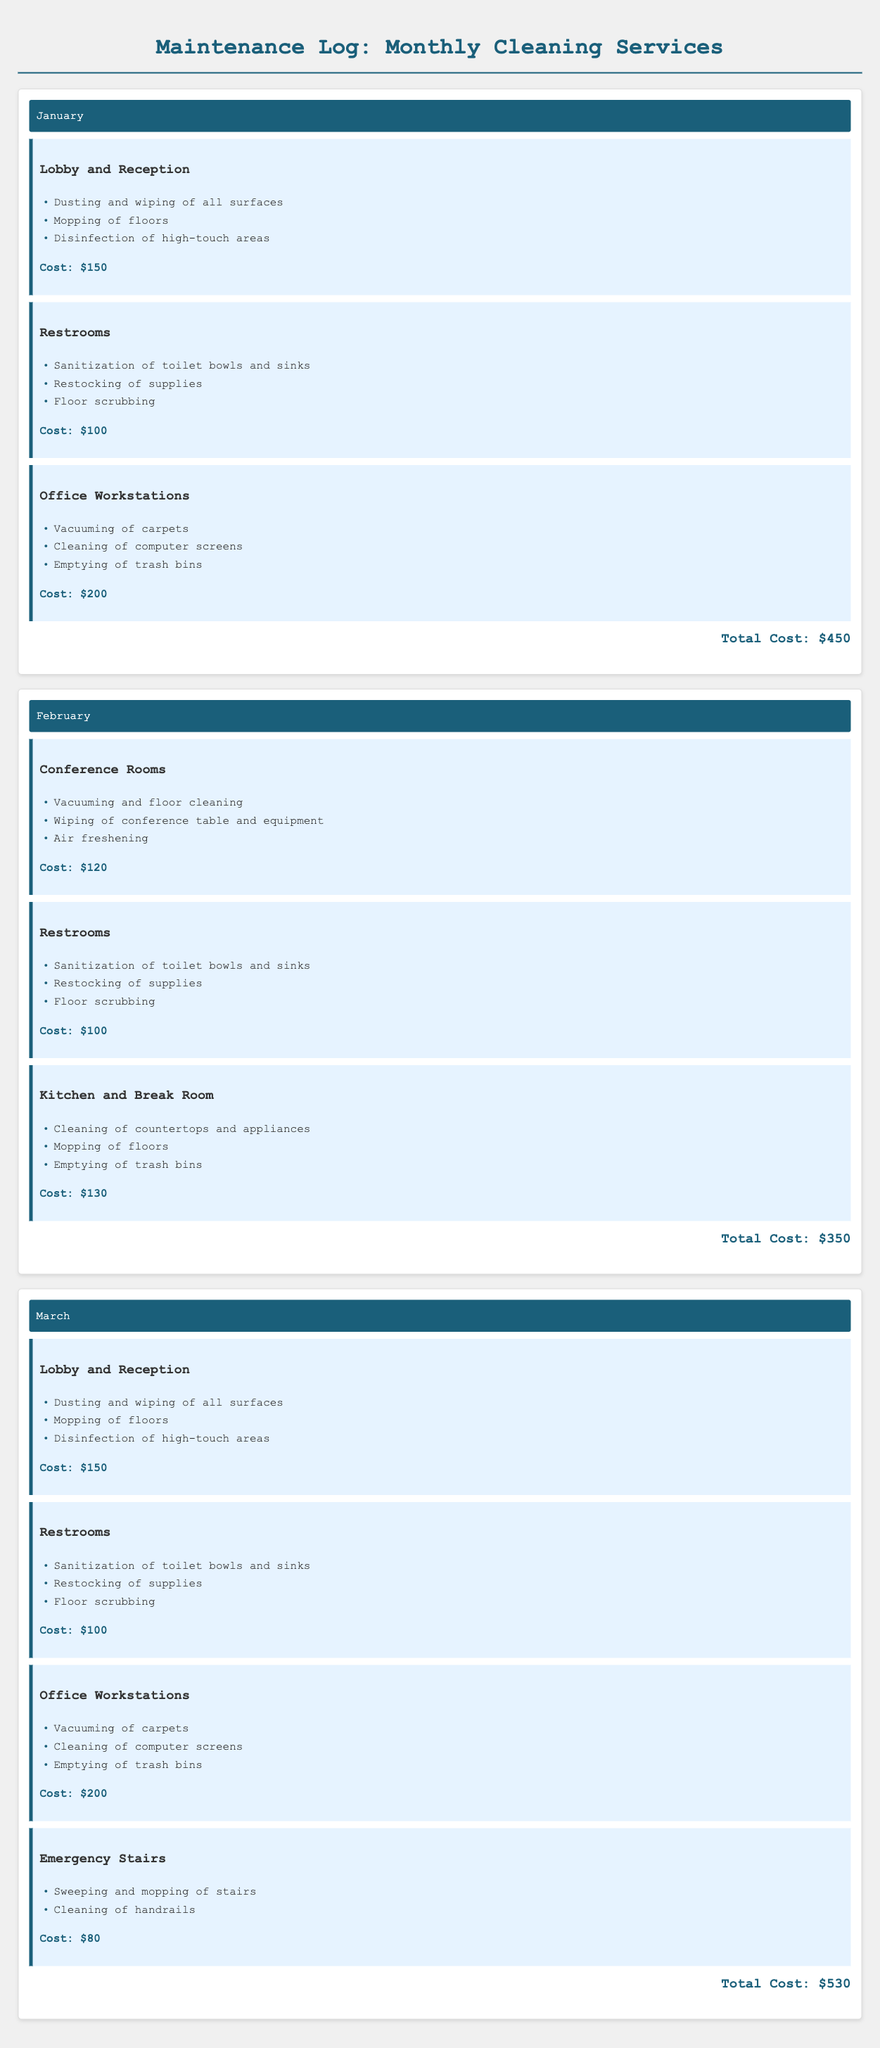What is the total cost for January? The total cost for January is given at the end of that section, which adds up the costs of various areas covered.
Answer: $450 What services are performed in the Office Workstations for February? The services listed for the Office Workstations include vacuuming carpets, cleaning computer screens, and emptying trash bins for February.
Answer: Vacuuming of carpets, Cleaning of computer screens, Emptying of trash bins How much does it cost to clean the Restrooms in March? The Restrooms in March have a specific cost listed, which is shown in the document for that month.
Answer: $100 What areas were cleaned in March? The document lists the areas that were cleaned in March, which includes Lobby and Reception, Restrooms, Office Workstations, and Emergency Stairs.
Answer: Lobby and Reception, Restrooms, Office Workstations, Emergency Stairs Which month has the highest total cleaning cost? By comparing the total costs listed for each month in the document, you can determine which month has the highest total cleaning cost.
Answer: March What is the cost for cleaning Conference Rooms in February? The cost for cleaning Conference Rooms in February is provided in the document with the specific services listed under that area for the month.
Answer: $120 What area has been covered consistently in all three months? The question asks for an area that appears in the cleaning service logs for every month, which you can find by scanning each month’s services.
Answer: Restrooms What specific service is performed in the Emergency Stairs? The services for Emergency Stairs are detailed under that area in the March section, allowing for identification of what is done there.
Answer: Sweeping and mopping of stairs, Cleaning of handrails 